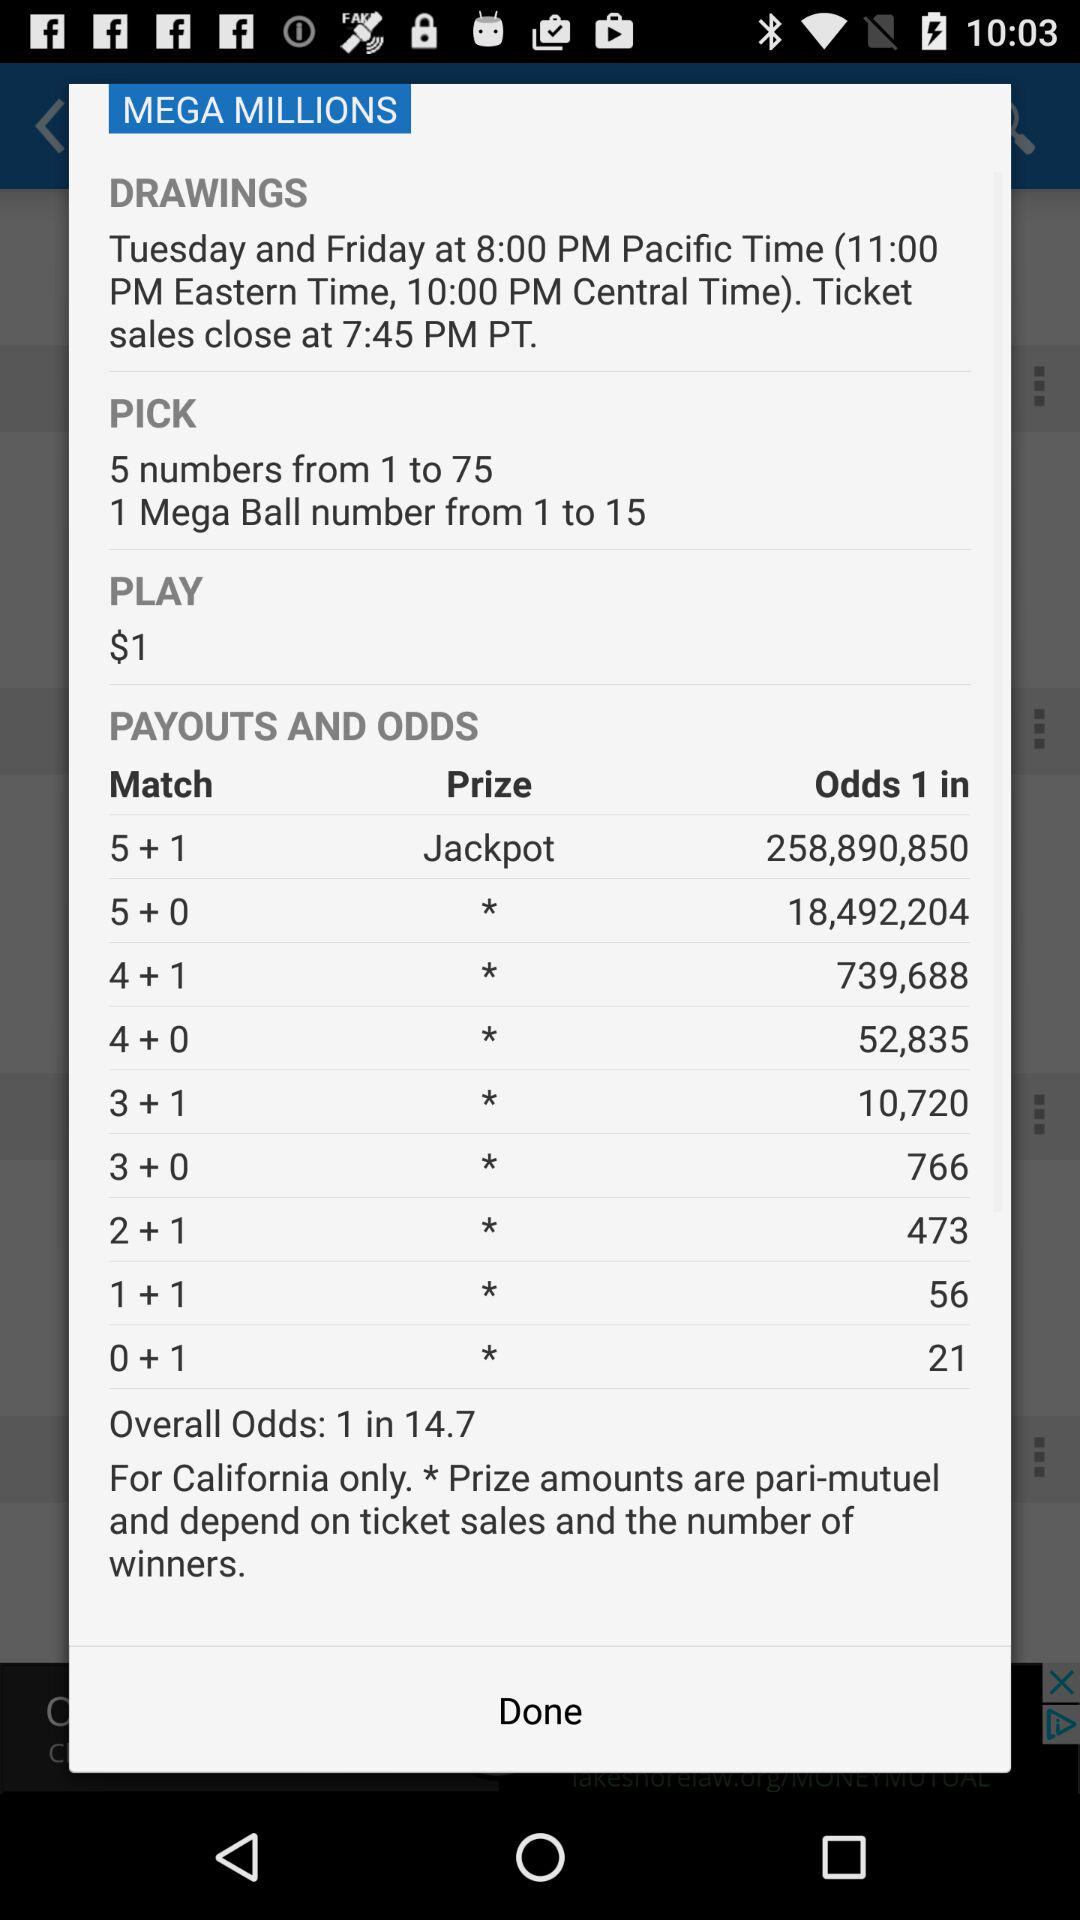What is the play amount? The play amount is $1. 